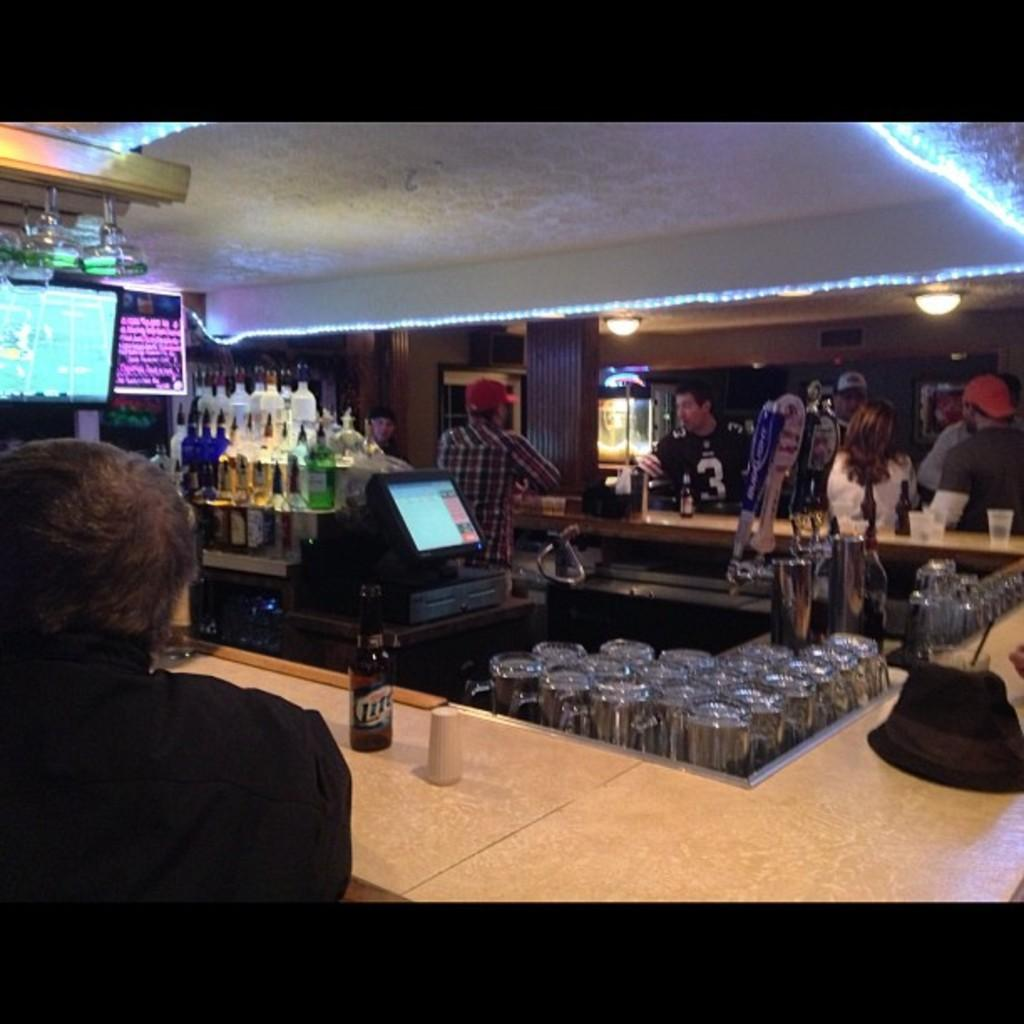Who or what is located at the front of the image? There is a person in the front of the image. What objects are in the center of the image? There are bottles, glasses, and a monitor in the center of the image. Can you describe the people in the background of the image? There are persons in the background of the image. What can be seen at the top of the image? There are lights visible at the top of the image. What type of milk is being poured into the bottles in the image? There is no milk present in the image; it features bottles, glasses, and a monitor. How many divisions are visible in the image? There is no division present in the image; it is a single scene featuring a person, bottles, glasses, a monitor, persons in the background, and lights at the top. 